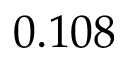Convert formula to latex. <formula><loc_0><loc_0><loc_500><loc_500>0 . 1 0 8</formula> 